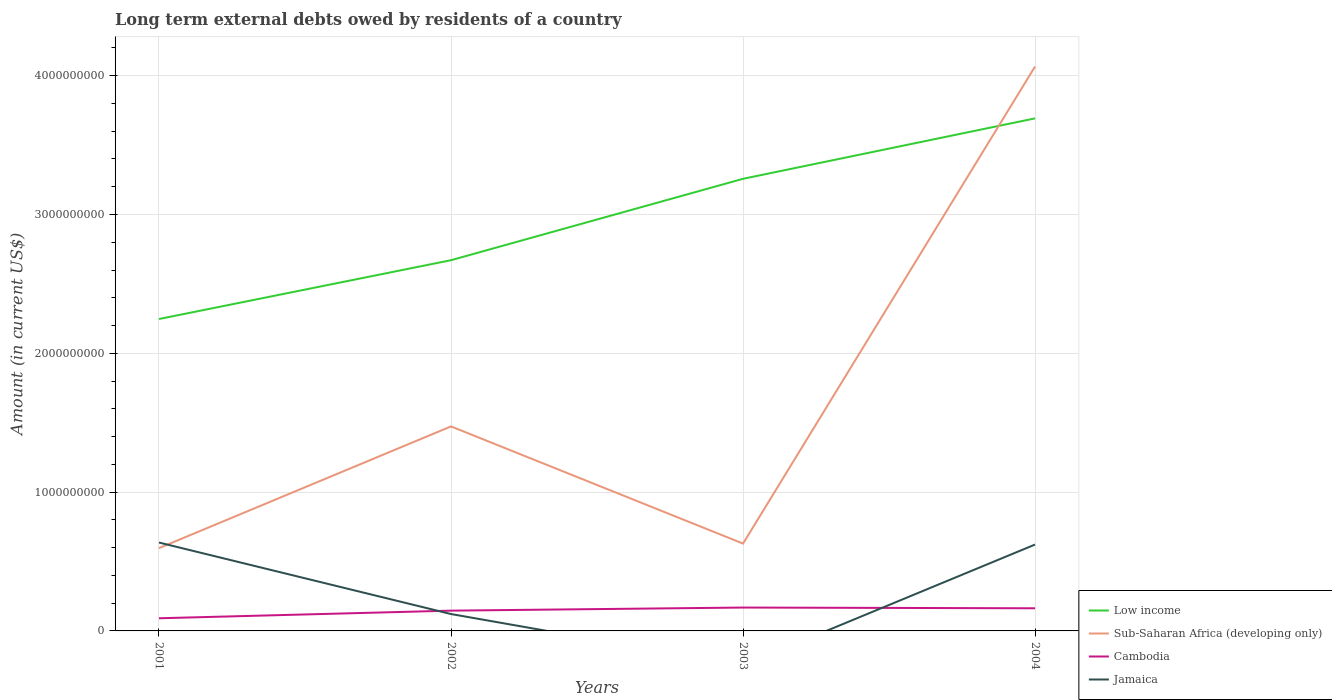Does the line corresponding to Low income intersect with the line corresponding to Sub-Saharan Africa (developing only)?
Keep it short and to the point. Yes. Across all years, what is the maximum amount of long-term external debts owed by residents in Sub-Saharan Africa (developing only)?
Make the answer very short. 5.96e+08. What is the total amount of long-term external debts owed by residents in Low income in the graph?
Provide a succinct answer. -4.35e+08. What is the difference between the highest and the second highest amount of long-term external debts owed by residents in Sub-Saharan Africa (developing only)?
Keep it short and to the point. 3.47e+09. How many lines are there?
Provide a succinct answer. 4. Are the values on the major ticks of Y-axis written in scientific E-notation?
Provide a succinct answer. No. Does the graph contain any zero values?
Your answer should be compact. Yes. Does the graph contain grids?
Provide a short and direct response. Yes. How many legend labels are there?
Provide a short and direct response. 4. What is the title of the graph?
Provide a short and direct response. Long term external debts owed by residents of a country. Does "Low income" appear as one of the legend labels in the graph?
Offer a terse response. Yes. What is the label or title of the Y-axis?
Ensure brevity in your answer.  Amount (in current US$). What is the Amount (in current US$) of Low income in 2001?
Offer a terse response. 2.25e+09. What is the Amount (in current US$) in Sub-Saharan Africa (developing only) in 2001?
Your response must be concise. 5.96e+08. What is the Amount (in current US$) of Cambodia in 2001?
Your answer should be compact. 9.11e+07. What is the Amount (in current US$) of Jamaica in 2001?
Make the answer very short. 6.37e+08. What is the Amount (in current US$) in Low income in 2002?
Provide a short and direct response. 2.67e+09. What is the Amount (in current US$) in Sub-Saharan Africa (developing only) in 2002?
Keep it short and to the point. 1.47e+09. What is the Amount (in current US$) of Cambodia in 2002?
Offer a very short reply. 1.46e+08. What is the Amount (in current US$) of Jamaica in 2002?
Make the answer very short. 1.22e+08. What is the Amount (in current US$) of Low income in 2003?
Offer a terse response. 3.26e+09. What is the Amount (in current US$) of Sub-Saharan Africa (developing only) in 2003?
Your response must be concise. 6.29e+08. What is the Amount (in current US$) of Cambodia in 2003?
Provide a succinct answer. 1.68e+08. What is the Amount (in current US$) in Jamaica in 2003?
Your response must be concise. 0. What is the Amount (in current US$) of Low income in 2004?
Give a very brief answer. 3.69e+09. What is the Amount (in current US$) of Sub-Saharan Africa (developing only) in 2004?
Offer a very short reply. 4.07e+09. What is the Amount (in current US$) in Cambodia in 2004?
Provide a succinct answer. 1.63e+08. What is the Amount (in current US$) in Jamaica in 2004?
Keep it short and to the point. 6.22e+08. Across all years, what is the maximum Amount (in current US$) of Low income?
Your answer should be compact. 3.69e+09. Across all years, what is the maximum Amount (in current US$) in Sub-Saharan Africa (developing only)?
Keep it short and to the point. 4.07e+09. Across all years, what is the maximum Amount (in current US$) of Cambodia?
Ensure brevity in your answer.  1.68e+08. Across all years, what is the maximum Amount (in current US$) in Jamaica?
Your response must be concise. 6.37e+08. Across all years, what is the minimum Amount (in current US$) in Low income?
Provide a succinct answer. 2.25e+09. Across all years, what is the minimum Amount (in current US$) in Sub-Saharan Africa (developing only)?
Ensure brevity in your answer.  5.96e+08. Across all years, what is the minimum Amount (in current US$) of Cambodia?
Offer a terse response. 9.11e+07. Across all years, what is the minimum Amount (in current US$) in Jamaica?
Your response must be concise. 0. What is the total Amount (in current US$) in Low income in the graph?
Make the answer very short. 1.19e+1. What is the total Amount (in current US$) in Sub-Saharan Africa (developing only) in the graph?
Offer a very short reply. 6.76e+09. What is the total Amount (in current US$) in Cambodia in the graph?
Make the answer very short. 5.69e+08. What is the total Amount (in current US$) in Jamaica in the graph?
Make the answer very short. 1.38e+09. What is the difference between the Amount (in current US$) in Low income in 2001 and that in 2002?
Provide a succinct answer. -4.24e+08. What is the difference between the Amount (in current US$) in Sub-Saharan Africa (developing only) in 2001 and that in 2002?
Provide a short and direct response. -8.77e+08. What is the difference between the Amount (in current US$) of Cambodia in 2001 and that in 2002?
Give a very brief answer. -5.50e+07. What is the difference between the Amount (in current US$) in Jamaica in 2001 and that in 2002?
Provide a succinct answer. 5.15e+08. What is the difference between the Amount (in current US$) in Low income in 2001 and that in 2003?
Your response must be concise. -1.01e+09. What is the difference between the Amount (in current US$) of Sub-Saharan Africa (developing only) in 2001 and that in 2003?
Your response must be concise. -3.28e+07. What is the difference between the Amount (in current US$) of Cambodia in 2001 and that in 2003?
Provide a short and direct response. -7.72e+07. What is the difference between the Amount (in current US$) in Low income in 2001 and that in 2004?
Ensure brevity in your answer.  -1.45e+09. What is the difference between the Amount (in current US$) of Sub-Saharan Africa (developing only) in 2001 and that in 2004?
Provide a succinct answer. -3.47e+09. What is the difference between the Amount (in current US$) in Cambodia in 2001 and that in 2004?
Offer a terse response. -7.20e+07. What is the difference between the Amount (in current US$) in Jamaica in 2001 and that in 2004?
Offer a terse response. 1.46e+07. What is the difference between the Amount (in current US$) of Low income in 2002 and that in 2003?
Give a very brief answer. -5.86e+08. What is the difference between the Amount (in current US$) of Sub-Saharan Africa (developing only) in 2002 and that in 2003?
Offer a terse response. 8.44e+08. What is the difference between the Amount (in current US$) in Cambodia in 2002 and that in 2003?
Ensure brevity in your answer.  -2.22e+07. What is the difference between the Amount (in current US$) in Low income in 2002 and that in 2004?
Keep it short and to the point. -1.02e+09. What is the difference between the Amount (in current US$) of Sub-Saharan Africa (developing only) in 2002 and that in 2004?
Make the answer very short. -2.59e+09. What is the difference between the Amount (in current US$) in Cambodia in 2002 and that in 2004?
Your answer should be compact. -1.70e+07. What is the difference between the Amount (in current US$) of Jamaica in 2002 and that in 2004?
Your answer should be compact. -5.01e+08. What is the difference between the Amount (in current US$) of Low income in 2003 and that in 2004?
Ensure brevity in your answer.  -4.35e+08. What is the difference between the Amount (in current US$) of Sub-Saharan Africa (developing only) in 2003 and that in 2004?
Offer a very short reply. -3.44e+09. What is the difference between the Amount (in current US$) in Cambodia in 2003 and that in 2004?
Your response must be concise. 5.23e+06. What is the difference between the Amount (in current US$) of Low income in 2001 and the Amount (in current US$) of Sub-Saharan Africa (developing only) in 2002?
Ensure brevity in your answer.  7.74e+08. What is the difference between the Amount (in current US$) of Low income in 2001 and the Amount (in current US$) of Cambodia in 2002?
Make the answer very short. 2.10e+09. What is the difference between the Amount (in current US$) of Low income in 2001 and the Amount (in current US$) of Jamaica in 2002?
Make the answer very short. 2.13e+09. What is the difference between the Amount (in current US$) in Sub-Saharan Africa (developing only) in 2001 and the Amount (in current US$) in Cambodia in 2002?
Your answer should be compact. 4.50e+08. What is the difference between the Amount (in current US$) in Sub-Saharan Africa (developing only) in 2001 and the Amount (in current US$) in Jamaica in 2002?
Your answer should be compact. 4.75e+08. What is the difference between the Amount (in current US$) of Cambodia in 2001 and the Amount (in current US$) of Jamaica in 2002?
Your answer should be compact. -3.05e+07. What is the difference between the Amount (in current US$) in Low income in 2001 and the Amount (in current US$) in Sub-Saharan Africa (developing only) in 2003?
Your response must be concise. 1.62e+09. What is the difference between the Amount (in current US$) in Low income in 2001 and the Amount (in current US$) in Cambodia in 2003?
Make the answer very short. 2.08e+09. What is the difference between the Amount (in current US$) in Sub-Saharan Africa (developing only) in 2001 and the Amount (in current US$) in Cambodia in 2003?
Provide a short and direct response. 4.28e+08. What is the difference between the Amount (in current US$) of Low income in 2001 and the Amount (in current US$) of Sub-Saharan Africa (developing only) in 2004?
Make the answer very short. -1.82e+09. What is the difference between the Amount (in current US$) in Low income in 2001 and the Amount (in current US$) in Cambodia in 2004?
Your answer should be compact. 2.08e+09. What is the difference between the Amount (in current US$) of Low income in 2001 and the Amount (in current US$) of Jamaica in 2004?
Keep it short and to the point. 1.62e+09. What is the difference between the Amount (in current US$) in Sub-Saharan Africa (developing only) in 2001 and the Amount (in current US$) in Cambodia in 2004?
Provide a succinct answer. 4.33e+08. What is the difference between the Amount (in current US$) of Sub-Saharan Africa (developing only) in 2001 and the Amount (in current US$) of Jamaica in 2004?
Provide a succinct answer. -2.58e+07. What is the difference between the Amount (in current US$) in Cambodia in 2001 and the Amount (in current US$) in Jamaica in 2004?
Ensure brevity in your answer.  -5.31e+08. What is the difference between the Amount (in current US$) of Low income in 2002 and the Amount (in current US$) of Sub-Saharan Africa (developing only) in 2003?
Provide a short and direct response. 2.04e+09. What is the difference between the Amount (in current US$) in Low income in 2002 and the Amount (in current US$) in Cambodia in 2003?
Offer a very short reply. 2.50e+09. What is the difference between the Amount (in current US$) in Sub-Saharan Africa (developing only) in 2002 and the Amount (in current US$) in Cambodia in 2003?
Keep it short and to the point. 1.30e+09. What is the difference between the Amount (in current US$) in Low income in 2002 and the Amount (in current US$) in Sub-Saharan Africa (developing only) in 2004?
Your answer should be compact. -1.40e+09. What is the difference between the Amount (in current US$) of Low income in 2002 and the Amount (in current US$) of Cambodia in 2004?
Your response must be concise. 2.51e+09. What is the difference between the Amount (in current US$) in Low income in 2002 and the Amount (in current US$) in Jamaica in 2004?
Give a very brief answer. 2.05e+09. What is the difference between the Amount (in current US$) in Sub-Saharan Africa (developing only) in 2002 and the Amount (in current US$) in Cambodia in 2004?
Make the answer very short. 1.31e+09. What is the difference between the Amount (in current US$) of Sub-Saharan Africa (developing only) in 2002 and the Amount (in current US$) of Jamaica in 2004?
Ensure brevity in your answer.  8.51e+08. What is the difference between the Amount (in current US$) of Cambodia in 2002 and the Amount (in current US$) of Jamaica in 2004?
Offer a very short reply. -4.76e+08. What is the difference between the Amount (in current US$) in Low income in 2003 and the Amount (in current US$) in Sub-Saharan Africa (developing only) in 2004?
Your response must be concise. -8.09e+08. What is the difference between the Amount (in current US$) in Low income in 2003 and the Amount (in current US$) in Cambodia in 2004?
Ensure brevity in your answer.  3.09e+09. What is the difference between the Amount (in current US$) of Low income in 2003 and the Amount (in current US$) of Jamaica in 2004?
Keep it short and to the point. 2.63e+09. What is the difference between the Amount (in current US$) of Sub-Saharan Africa (developing only) in 2003 and the Amount (in current US$) of Cambodia in 2004?
Make the answer very short. 4.66e+08. What is the difference between the Amount (in current US$) in Sub-Saharan Africa (developing only) in 2003 and the Amount (in current US$) in Jamaica in 2004?
Your answer should be very brief. 7.00e+06. What is the difference between the Amount (in current US$) of Cambodia in 2003 and the Amount (in current US$) of Jamaica in 2004?
Offer a very short reply. -4.54e+08. What is the average Amount (in current US$) of Low income per year?
Your response must be concise. 2.97e+09. What is the average Amount (in current US$) in Sub-Saharan Africa (developing only) per year?
Your answer should be very brief. 1.69e+09. What is the average Amount (in current US$) in Cambodia per year?
Keep it short and to the point. 1.42e+08. What is the average Amount (in current US$) in Jamaica per year?
Make the answer very short. 3.45e+08. In the year 2001, what is the difference between the Amount (in current US$) in Low income and Amount (in current US$) in Sub-Saharan Africa (developing only)?
Ensure brevity in your answer.  1.65e+09. In the year 2001, what is the difference between the Amount (in current US$) of Low income and Amount (in current US$) of Cambodia?
Offer a very short reply. 2.16e+09. In the year 2001, what is the difference between the Amount (in current US$) in Low income and Amount (in current US$) in Jamaica?
Ensure brevity in your answer.  1.61e+09. In the year 2001, what is the difference between the Amount (in current US$) of Sub-Saharan Africa (developing only) and Amount (in current US$) of Cambodia?
Ensure brevity in your answer.  5.05e+08. In the year 2001, what is the difference between the Amount (in current US$) in Sub-Saharan Africa (developing only) and Amount (in current US$) in Jamaica?
Make the answer very short. -4.04e+07. In the year 2001, what is the difference between the Amount (in current US$) of Cambodia and Amount (in current US$) of Jamaica?
Your response must be concise. -5.46e+08. In the year 2002, what is the difference between the Amount (in current US$) in Low income and Amount (in current US$) in Sub-Saharan Africa (developing only)?
Keep it short and to the point. 1.20e+09. In the year 2002, what is the difference between the Amount (in current US$) of Low income and Amount (in current US$) of Cambodia?
Your answer should be very brief. 2.52e+09. In the year 2002, what is the difference between the Amount (in current US$) in Low income and Amount (in current US$) in Jamaica?
Provide a short and direct response. 2.55e+09. In the year 2002, what is the difference between the Amount (in current US$) of Sub-Saharan Africa (developing only) and Amount (in current US$) of Cambodia?
Your response must be concise. 1.33e+09. In the year 2002, what is the difference between the Amount (in current US$) of Sub-Saharan Africa (developing only) and Amount (in current US$) of Jamaica?
Offer a terse response. 1.35e+09. In the year 2002, what is the difference between the Amount (in current US$) in Cambodia and Amount (in current US$) in Jamaica?
Your answer should be very brief. 2.45e+07. In the year 2003, what is the difference between the Amount (in current US$) in Low income and Amount (in current US$) in Sub-Saharan Africa (developing only)?
Provide a short and direct response. 2.63e+09. In the year 2003, what is the difference between the Amount (in current US$) of Low income and Amount (in current US$) of Cambodia?
Offer a very short reply. 3.09e+09. In the year 2003, what is the difference between the Amount (in current US$) in Sub-Saharan Africa (developing only) and Amount (in current US$) in Cambodia?
Give a very brief answer. 4.61e+08. In the year 2004, what is the difference between the Amount (in current US$) of Low income and Amount (in current US$) of Sub-Saharan Africa (developing only)?
Ensure brevity in your answer.  -3.74e+08. In the year 2004, what is the difference between the Amount (in current US$) in Low income and Amount (in current US$) in Cambodia?
Keep it short and to the point. 3.53e+09. In the year 2004, what is the difference between the Amount (in current US$) of Low income and Amount (in current US$) of Jamaica?
Your answer should be very brief. 3.07e+09. In the year 2004, what is the difference between the Amount (in current US$) of Sub-Saharan Africa (developing only) and Amount (in current US$) of Cambodia?
Provide a succinct answer. 3.90e+09. In the year 2004, what is the difference between the Amount (in current US$) in Sub-Saharan Africa (developing only) and Amount (in current US$) in Jamaica?
Provide a succinct answer. 3.44e+09. In the year 2004, what is the difference between the Amount (in current US$) of Cambodia and Amount (in current US$) of Jamaica?
Ensure brevity in your answer.  -4.59e+08. What is the ratio of the Amount (in current US$) in Low income in 2001 to that in 2002?
Offer a terse response. 0.84. What is the ratio of the Amount (in current US$) of Sub-Saharan Africa (developing only) in 2001 to that in 2002?
Ensure brevity in your answer.  0.4. What is the ratio of the Amount (in current US$) of Cambodia in 2001 to that in 2002?
Offer a terse response. 0.62. What is the ratio of the Amount (in current US$) of Jamaica in 2001 to that in 2002?
Provide a succinct answer. 5.23. What is the ratio of the Amount (in current US$) of Low income in 2001 to that in 2003?
Provide a short and direct response. 0.69. What is the ratio of the Amount (in current US$) of Sub-Saharan Africa (developing only) in 2001 to that in 2003?
Provide a short and direct response. 0.95. What is the ratio of the Amount (in current US$) in Cambodia in 2001 to that in 2003?
Your answer should be compact. 0.54. What is the ratio of the Amount (in current US$) in Low income in 2001 to that in 2004?
Give a very brief answer. 0.61. What is the ratio of the Amount (in current US$) of Sub-Saharan Africa (developing only) in 2001 to that in 2004?
Offer a terse response. 0.15. What is the ratio of the Amount (in current US$) in Cambodia in 2001 to that in 2004?
Your answer should be compact. 0.56. What is the ratio of the Amount (in current US$) in Jamaica in 2001 to that in 2004?
Give a very brief answer. 1.02. What is the ratio of the Amount (in current US$) in Low income in 2002 to that in 2003?
Provide a succinct answer. 0.82. What is the ratio of the Amount (in current US$) in Sub-Saharan Africa (developing only) in 2002 to that in 2003?
Your response must be concise. 2.34. What is the ratio of the Amount (in current US$) in Cambodia in 2002 to that in 2003?
Keep it short and to the point. 0.87. What is the ratio of the Amount (in current US$) of Low income in 2002 to that in 2004?
Your response must be concise. 0.72. What is the ratio of the Amount (in current US$) of Sub-Saharan Africa (developing only) in 2002 to that in 2004?
Your answer should be compact. 0.36. What is the ratio of the Amount (in current US$) in Cambodia in 2002 to that in 2004?
Offer a terse response. 0.9. What is the ratio of the Amount (in current US$) of Jamaica in 2002 to that in 2004?
Provide a short and direct response. 0.2. What is the ratio of the Amount (in current US$) of Low income in 2003 to that in 2004?
Your response must be concise. 0.88. What is the ratio of the Amount (in current US$) in Sub-Saharan Africa (developing only) in 2003 to that in 2004?
Your answer should be very brief. 0.15. What is the ratio of the Amount (in current US$) of Cambodia in 2003 to that in 2004?
Provide a short and direct response. 1.03. What is the difference between the highest and the second highest Amount (in current US$) of Low income?
Provide a succinct answer. 4.35e+08. What is the difference between the highest and the second highest Amount (in current US$) in Sub-Saharan Africa (developing only)?
Give a very brief answer. 2.59e+09. What is the difference between the highest and the second highest Amount (in current US$) in Cambodia?
Provide a succinct answer. 5.23e+06. What is the difference between the highest and the second highest Amount (in current US$) of Jamaica?
Your response must be concise. 1.46e+07. What is the difference between the highest and the lowest Amount (in current US$) of Low income?
Offer a terse response. 1.45e+09. What is the difference between the highest and the lowest Amount (in current US$) of Sub-Saharan Africa (developing only)?
Keep it short and to the point. 3.47e+09. What is the difference between the highest and the lowest Amount (in current US$) in Cambodia?
Your answer should be very brief. 7.72e+07. What is the difference between the highest and the lowest Amount (in current US$) of Jamaica?
Offer a terse response. 6.37e+08. 